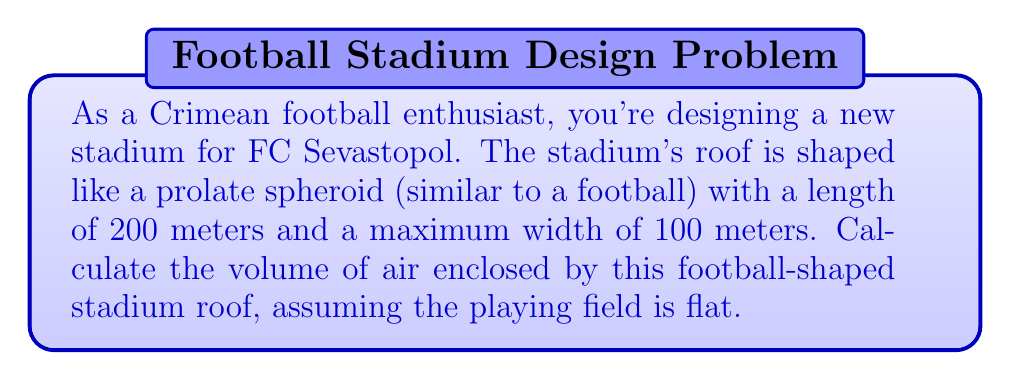Could you help me with this problem? Let's approach this step-by-step:

1) A prolate spheroid is formed by rotating an ellipse around its major axis. In this case:
   - Length (2a) = 200 m
   - Maximum width (2b) = 100 m

2) The volume of a prolate spheroid is given by the formula:

   $$V = \frac{4}{3}\pi a b^2$$

   Where $a$ is half the length and $b$ is half the maximum width.

3) Calculate $a$ and $b$:
   $a = 200/2 = 100$ m
   $b = 100/2 = 50$ m

4) Substitute these values into the formula:

   $$V = \frac{4}{3}\pi (100)(50)^2$$

5) Simplify:
   $$V = \frac{4}{3}\pi (100)(2500)$$
   $$V = \frac{4}{3}\pi (250000)$$
   $$V = \frac{1000000\pi}{3}$$

6) Calculate the final value:
   $$V \approx 1,047,197.55 \text{ m}^3$$

[asy]
import three;

size(200);
currentprojection=perspective(6,3,2);

revolution r = revolution(scale(50,25)*unitcircle, axis=Z);
draw(surface(r), lightgray);
draw(r, black);

label("200 m", (0,-30,0), S);
label("100 m", (55,0,0), E);
[/asy]
Answer: $\frac{1000000\pi}{3} \text{ m}^3$ or approximately $1,047,197.55 \text{ m}^3$ 